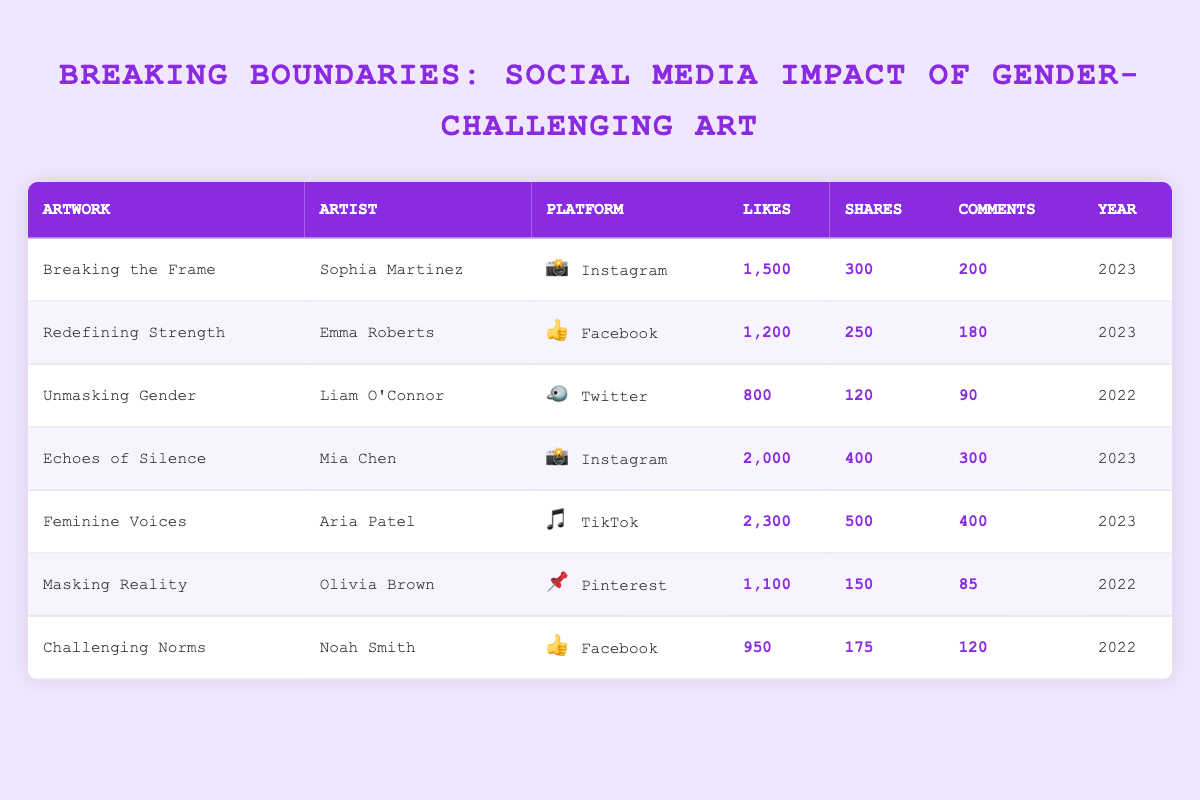What artwork received the highest number of likes? By looking at the "Likes" column in the table, "Feminine Voices" by Aria Patel has the highest value of 2300, which is greater than any other artwork's likes.
Answer: Feminine Voices Which platform has the most artworks showcasing in the table? The artworks listed show Instagram (2), Facebook (2), Twitter (1), TikTok (1), and Pinterest (1). Instagram is the most frequent platform, with 2 artworks.
Answer: Instagram What is the total number of comments across all artworks? To find the total comments, sum the "Comments" values: 200 (Breaking the Frame) + 180 (Redefining Strength) + 90 (Unmasking Gender) + 300 (Echoes of Silence) + 400 (Feminine Voices) + 85 (Masking Reality) + 120 (Challenging Norms) = 1375.
Answer: 1375 Does the artwork "Challenging Norms" have more shares than "Masking Reality"? "Challenging Norms" has 175 shares while "Masking Reality" has 150 shares, so it is true that "Challenging Norms" has more shares.
Answer: Yes What is the average number of likes for artworks in 2022? Filter the artworks for the year 2022, which are "Unmasking Gender" (800), "Masking Reality" (1100), and "Challenging Norms" (950). The average is calculated as (800 + 1100 + 950)/3 = 950.
Answer: 950 Which artist had an artwork with the least number of comments? By reviewing the "Comments" column, "Masking Reality" by Olivia Brown has the lowest comment count of 85 compared to others.
Answer: Olivia Brown How many total shares did artworks on TikTok accumulate? The artwork "Feminine Voices" is the only one on TikTok, with 500 shares, so the total from TikTok is simply the shares of this single artwork.
Answer: 500 Are there any artworks from 2023 with over 250 shares? "Breaking the Frame" (300 shares), "Echoes of Silence" (400 shares), and "Feminine Voices" (500 shares) all have more than 250 shares, so it is true that there are such artworks from 2023.
Answer: Yes 